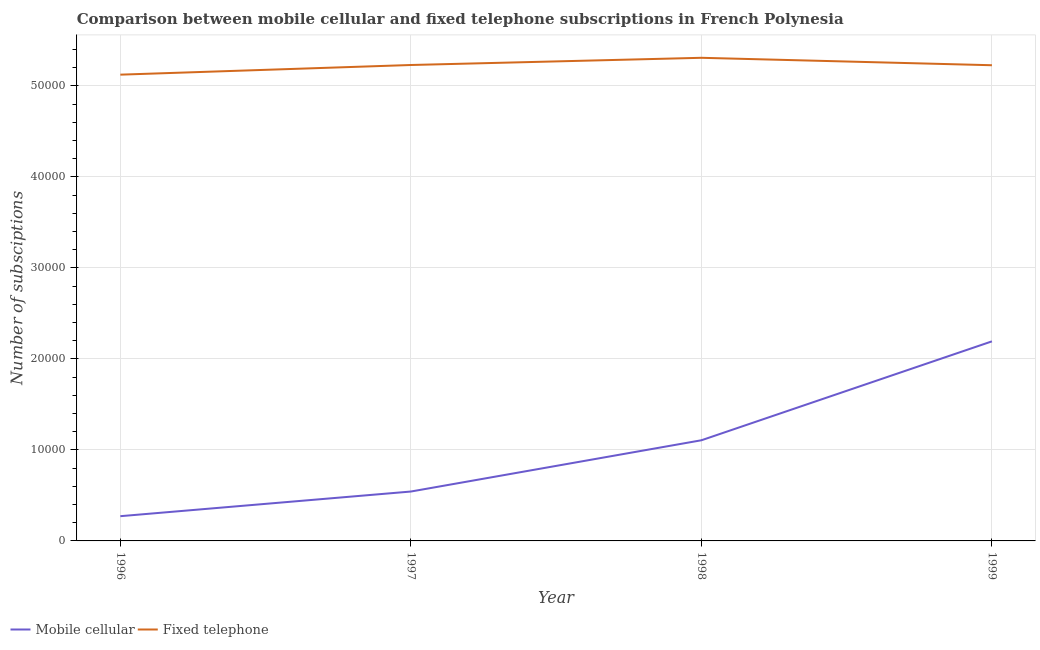Does the line corresponding to number of mobile cellular subscriptions intersect with the line corresponding to number of fixed telephone subscriptions?
Give a very brief answer. No. Is the number of lines equal to the number of legend labels?
Ensure brevity in your answer.  Yes. What is the number of fixed telephone subscriptions in 1996?
Your response must be concise. 5.12e+04. Across all years, what is the maximum number of mobile cellular subscriptions?
Make the answer very short. 2.19e+04. Across all years, what is the minimum number of fixed telephone subscriptions?
Your answer should be compact. 5.12e+04. What is the total number of fixed telephone subscriptions in the graph?
Provide a succinct answer. 2.09e+05. What is the difference between the number of mobile cellular subscriptions in 1997 and that in 1998?
Ensure brevity in your answer.  -5633. What is the difference between the number of fixed telephone subscriptions in 1999 and the number of mobile cellular subscriptions in 1997?
Your answer should be very brief. 4.68e+04. What is the average number of mobile cellular subscriptions per year?
Your answer should be compact. 1.03e+04. In the year 1996, what is the difference between the number of mobile cellular subscriptions and number of fixed telephone subscriptions?
Make the answer very short. -4.85e+04. What is the ratio of the number of fixed telephone subscriptions in 1998 to that in 1999?
Your answer should be very brief. 1.02. Is the number of mobile cellular subscriptions in 1997 less than that in 1999?
Keep it short and to the point. Yes. Is the difference between the number of mobile cellular subscriptions in 1996 and 1999 greater than the difference between the number of fixed telephone subscriptions in 1996 and 1999?
Offer a terse response. No. What is the difference between the highest and the second highest number of fixed telephone subscriptions?
Provide a succinct answer. 792. What is the difference between the highest and the lowest number of fixed telephone subscriptions?
Offer a very short reply. 1853. In how many years, is the number of mobile cellular subscriptions greater than the average number of mobile cellular subscriptions taken over all years?
Offer a terse response. 2. Does the number of mobile cellular subscriptions monotonically increase over the years?
Your response must be concise. Yes. Is the number of mobile cellular subscriptions strictly greater than the number of fixed telephone subscriptions over the years?
Your response must be concise. No. Is the number of mobile cellular subscriptions strictly less than the number of fixed telephone subscriptions over the years?
Give a very brief answer. Yes. Are the values on the major ticks of Y-axis written in scientific E-notation?
Ensure brevity in your answer.  No. Where does the legend appear in the graph?
Provide a succinct answer. Bottom left. How many legend labels are there?
Offer a very short reply. 2. How are the legend labels stacked?
Your answer should be very brief. Horizontal. What is the title of the graph?
Provide a succinct answer. Comparison between mobile cellular and fixed telephone subscriptions in French Polynesia. What is the label or title of the X-axis?
Your response must be concise. Year. What is the label or title of the Y-axis?
Provide a succinct answer. Number of subsciptions. What is the Number of subsciptions in Mobile cellular in 1996?
Offer a very short reply. 2719. What is the Number of subsciptions in Fixed telephone in 1996?
Offer a very short reply. 5.12e+04. What is the Number of subsciptions of Mobile cellular in 1997?
Your answer should be very brief. 5427. What is the Number of subsciptions in Fixed telephone in 1997?
Offer a very short reply. 5.23e+04. What is the Number of subsciptions in Mobile cellular in 1998?
Provide a succinct answer. 1.11e+04. What is the Number of subsciptions in Fixed telephone in 1998?
Your answer should be compact. 5.31e+04. What is the Number of subsciptions in Mobile cellular in 1999?
Keep it short and to the point. 2.19e+04. What is the Number of subsciptions in Fixed telephone in 1999?
Offer a terse response. 5.23e+04. Across all years, what is the maximum Number of subsciptions in Mobile cellular?
Ensure brevity in your answer.  2.19e+04. Across all years, what is the maximum Number of subsciptions of Fixed telephone?
Your response must be concise. 5.31e+04. Across all years, what is the minimum Number of subsciptions in Mobile cellular?
Provide a short and direct response. 2719. Across all years, what is the minimum Number of subsciptions in Fixed telephone?
Your answer should be compact. 5.12e+04. What is the total Number of subsciptions of Mobile cellular in the graph?
Keep it short and to the point. 4.11e+04. What is the total Number of subsciptions of Fixed telephone in the graph?
Provide a succinct answer. 2.09e+05. What is the difference between the Number of subsciptions in Mobile cellular in 1996 and that in 1997?
Offer a very short reply. -2708. What is the difference between the Number of subsciptions in Fixed telephone in 1996 and that in 1997?
Keep it short and to the point. -1061. What is the difference between the Number of subsciptions in Mobile cellular in 1996 and that in 1998?
Keep it short and to the point. -8341. What is the difference between the Number of subsciptions in Fixed telephone in 1996 and that in 1998?
Keep it short and to the point. -1853. What is the difference between the Number of subsciptions in Mobile cellular in 1996 and that in 1999?
Ensure brevity in your answer.  -1.92e+04. What is the difference between the Number of subsciptions in Fixed telephone in 1996 and that in 1999?
Provide a succinct answer. -1036. What is the difference between the Number of subsciptions of Mobile cellular in 1997 and that in 1998?
Keep it short and to the point. -5633. What is the difference between the Number of subsciptions in Fixed telephone in 1997 and that in 1998?
Ensure brevity in your answer.  -792. What is the difference between the Number of subsciptions of Mobile cellular in 1997 and that in 1999?
Your answer should be very brief. -1.65e+04. What is the difference between the Number of subsciptions in Mobile cellular in 1998 and that in 1999?
Give a very brief answer. -1.09e+04. What is the difference between the Number of subsciptions of Fixed telephone in 1998 and that in 1999?
Your response must be concise. 817. What is the difference between the Number of subsciptions of Mobile cellular in 1996 and the Number of subsciptions of Fixed telephone in 1997?
Make the answer very short. -4.96e+04. What is the difference between the Number of subsciptions of Mobile cellular in 1996 and the Number of subsciptions of Fixed telephone in 1998?
Your answer should be very brief. -5.04e+04. What is the difference between the Number of subsciptions of Mobile cellular in 1996 and the Number of subsciptions of Fixed telephone in 1999?
Give a very brief answer. -4.96e+04. What is the difference between the Number of subsciptions of Mobile cellular in 1997 and the Number of subsciptions of Fixed telephone in 1998?
Your response must be concise. -4.77e+04. What is the difference between the Number of subsciptions in Mobile cellular in 1997 and the Number of subsciptions in Fixed telephone in 1999?
Provide a short and direct response. -4.68e+04. What is the difference between the Number of subsciptions in Mobile cellular in 1998 and the Number of subsciptions in Fixed telephone in 1999?
Ensure brevity in your answer.  -4.12e+04. What is the average Number of subsciptions in Mobile cellular per year?
Ensure brevity in your answer.  1.03e+04. What is the average Number of subsciptions in Fixed telephone per year?
Give a very brief answer. 5.22e+04. In the year 1996, what is the difference between the Number of subsciptions in Mobile cellular and Number of subsciptions in Fixed telephone?
Offer a very short reply. -4.85e+04. In the year 1997, what is the difference between the Number of subsciptions of Mobile cellular and Number of subsciptions of Fixed telephone?
Provide a succinct answer. -4.69e+04. In the year 1998, what is the difference between the Number of subsciptions of Mobile cellular and Number of subsciptions of Fixed telephone?
Give a very brief answer. -4.20e+04. In the year 1999, what is the difference between the Number of subsciptions of Mobile cellular and Number of subsciptions of Fixed telephone?
Your answer should be compact. -3.03e+04. What is the ratio of the Number of subsciptions in Mobile cellular in 1996 to that in 1997?
Keep it short and to the point. 0.5. What is the ratio of the Number of subsciptions of Fixed telephone in 1996 to that in 1997?
Provide a succinct answer. 0.98. What is the ratio of the Number of subsciptions of Mobile cellular in 1996 to that in 1998?
Offer a very short reply. 0.25. What is the ratio of the Number of subsciptions in Fixed telephone in 1996 to that in 1998?
Your response must be concise. 0.97. What is the ratio of the Number of subsciptions in Mobile cellular in 1996 to that in 1999?
Provide a succinct answer. 0.12. What is the ratio of the Number of subsciptions of Fixed telephone in 1996 to that in 1999?
Offer a very short reply. 0.98. What is the ratio of the Number of subsciptions of Mobile cellular in 1997 to that in 1998?
Offer a terse response. 0.49. What is the ratio of the Number of subsciptions of Fixed telephone in 1997 to that in 1998?
Ensure brevity in your answer.  0.99. What is the ratio of the Number of subsciptions of Mobile cellular in 1997 to that in 1999?
Keep it short and to the point. 0.25. What is the ratio of the Number of subsciptions in Mobile cellular in 1998 to that in 1999?
Give a very brief answer. 0.5. What is the ratio of the Number of subsciptions in Fixed telephone in 1998 to that in 1999?
Provide a succinct answer. 1.02. What is the difference between the highest and the second highest Number of subsciptions of Mobile cellular?
Keep it short and to the point. 1.09e+04. What is the difference between the highest and the second highest Number of subsciptions of Fixed telephone?
Your answer should be compact. 792. What is the difference between the highest and the lowest Number of subsciptions of Mobile cellular?
Provide a short and direct response. 1.92e+04. What is the difference between the highest and the lowest Number of subsciptions in Fixed telephone?
Your answer should be compact. 1853. 